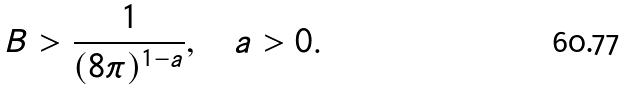Convert formula to latex. <formula><loc_0><loc_0><loc_500><loc_500>B > \frac { 1 } { ( 8 \pi ) ^ { 1 - a } } , \quad a > 0 .</formula> 